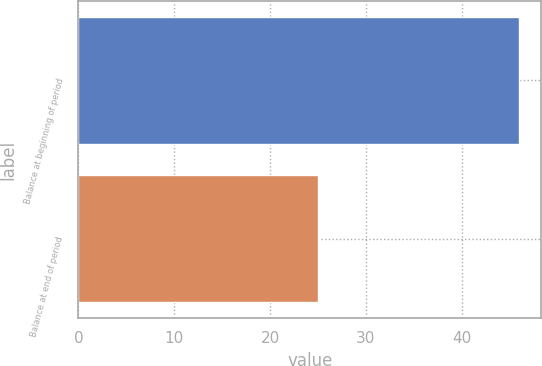Convert chart to OTSL. <chart><loc_0><loc_0><loc_500><loc_500><bar_chart><fcel>Balance at beginning of period<fcel>Balance at end of period<nl><fcel>46<fcel>25<nl></chart> 